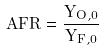Convert formula to latex. <formula><loc_0><loc_0><loc_500><loc_500>A F R = \frac { Y _ { O , 0 } } { Y _ { F , 0 } }</formula> 